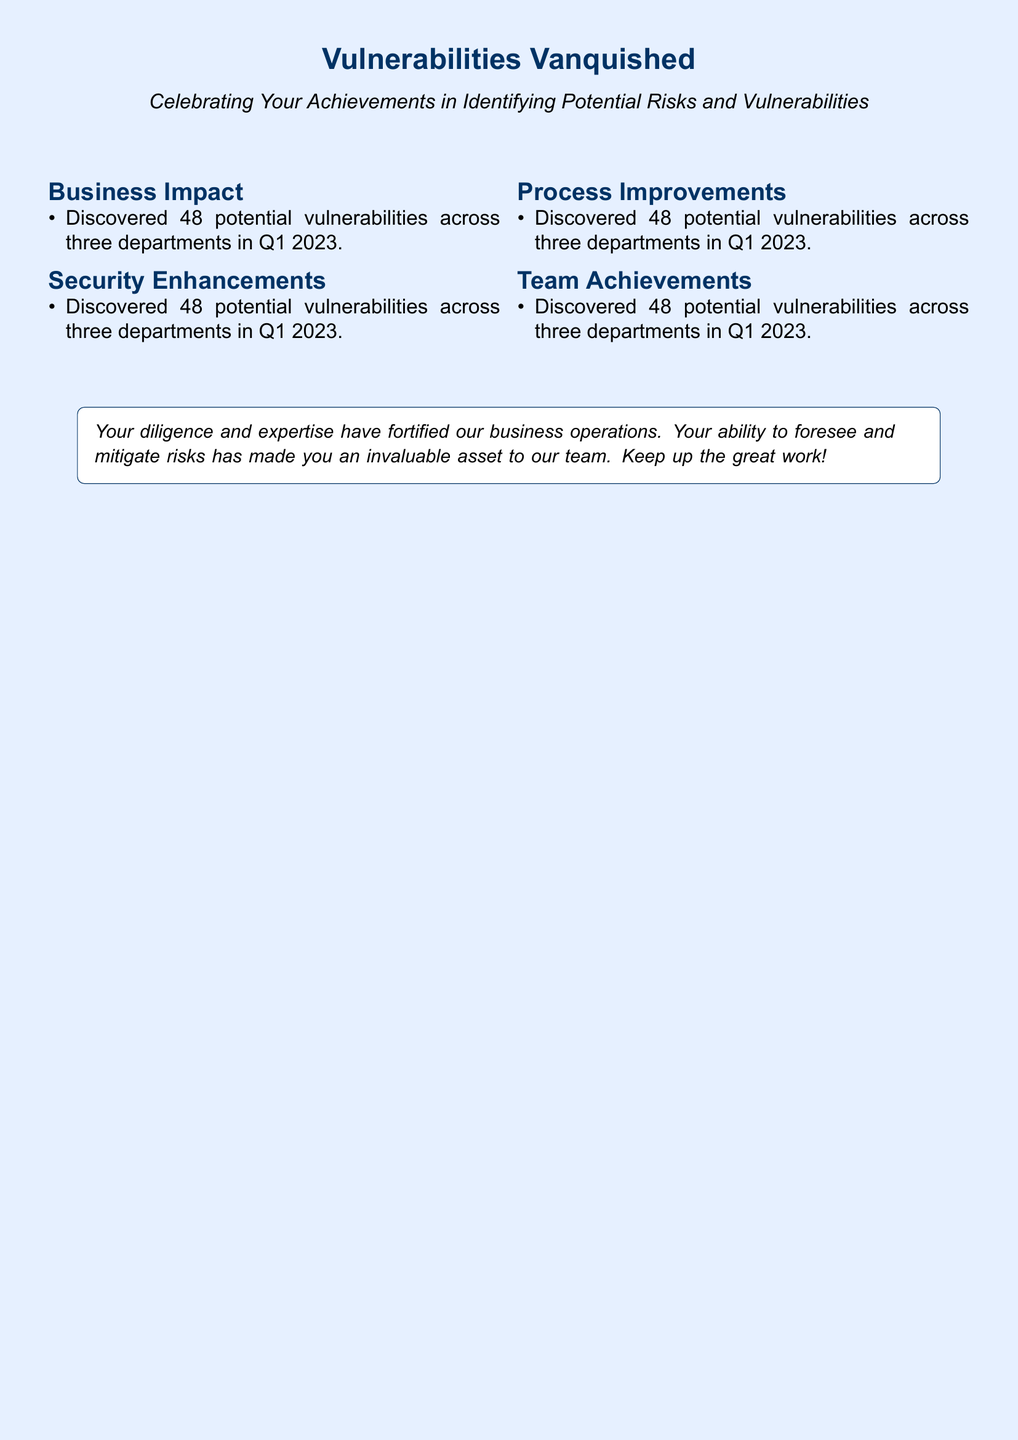What is the title of the card? The title of the card is prominently displayed at the top, highlighting the theme of achievements in risk identification.
Answer: Vulnerabilities Vanquished How many potential vulnerabilities were discovered? The document specifies the exact number of vulnerabilities found in a given timeframe as a key achievement.
Answer: 48 What was the percentage reduction in operational disruptions due to implemented fixes? This figure is presented as a quantifiable improvement resulting from the analyst's actions, showcasing effectiveness.
Answer: 30% How much money was saved annually by identifying inefficiencies in the logistics chain? The card highlights a significant financial impact from operational improvements made by the analyst, providing a solid figure.
Answer: $200,000 What type of authentication was integrated across all employee accounts? The document details specific measures implemented to enhance security within company operations.
Answer: Multi-factor authentication In which quarter of 2023 were the vulnerabilities identified? The timeframe of the discoveries is mentioned in the document, providing context to the achievements listed.
Answer: Q1 2023 How many employees were trained on identifying and mitigating risks? The card indicates the scale of efforts made in training and employee engagement as part of risk management strategies.
Answer: 200 What was the effect of enhanced data encryption protocols? This achievement is quantified in terms of risk reduction, emphasizing the importance of cybersecurity measures.
Answer: 25% reduction What is mentioned as a key element of the analyst's role in the company? The document states the analyst's contributions towards the team's overall performance and risk management capabilities.
Answer: Invaluable asset 